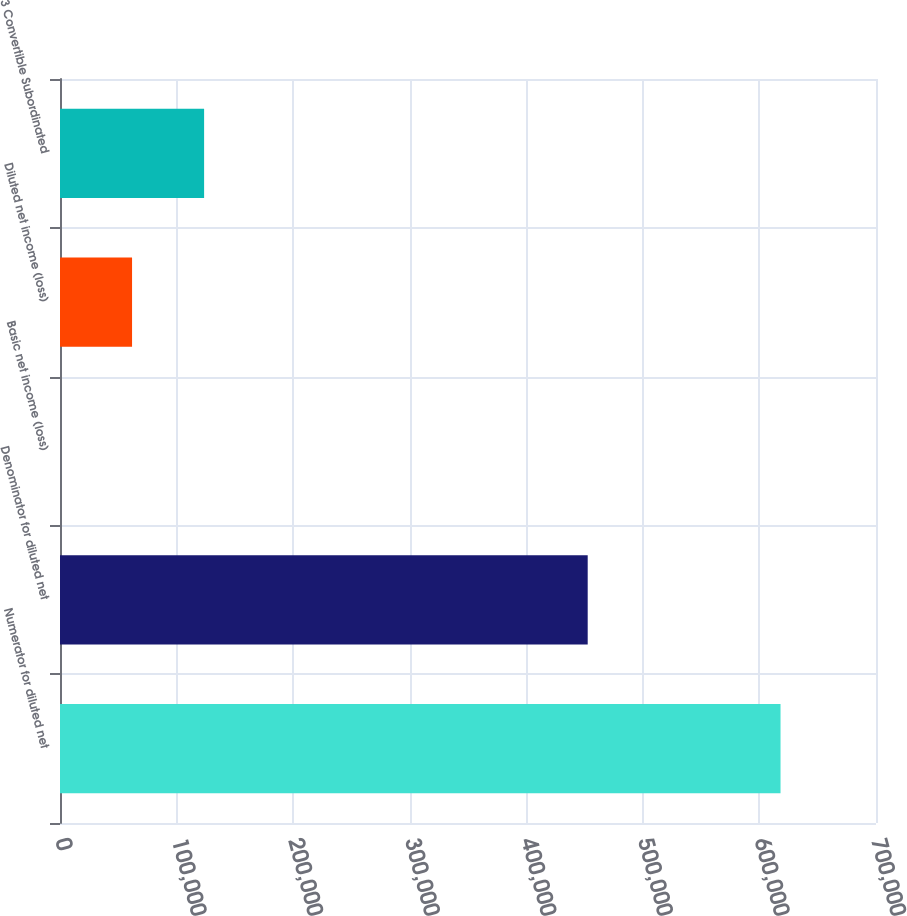Convert chart to OTSL. <chart><loc_0><loc_0><loc_500><loc_500><bar_chart><fcel>Numerator for diluted net<fcel>Denominator for diluted net<fcel>Basic net income (loss)<fcel>Diluted net income (loss)<fcel>3 Convertible Subordinated<nl><fcel>618106<fcel>452685<fcel>1.37<fcel>61811.8<fcel>123622<nl></chart> 